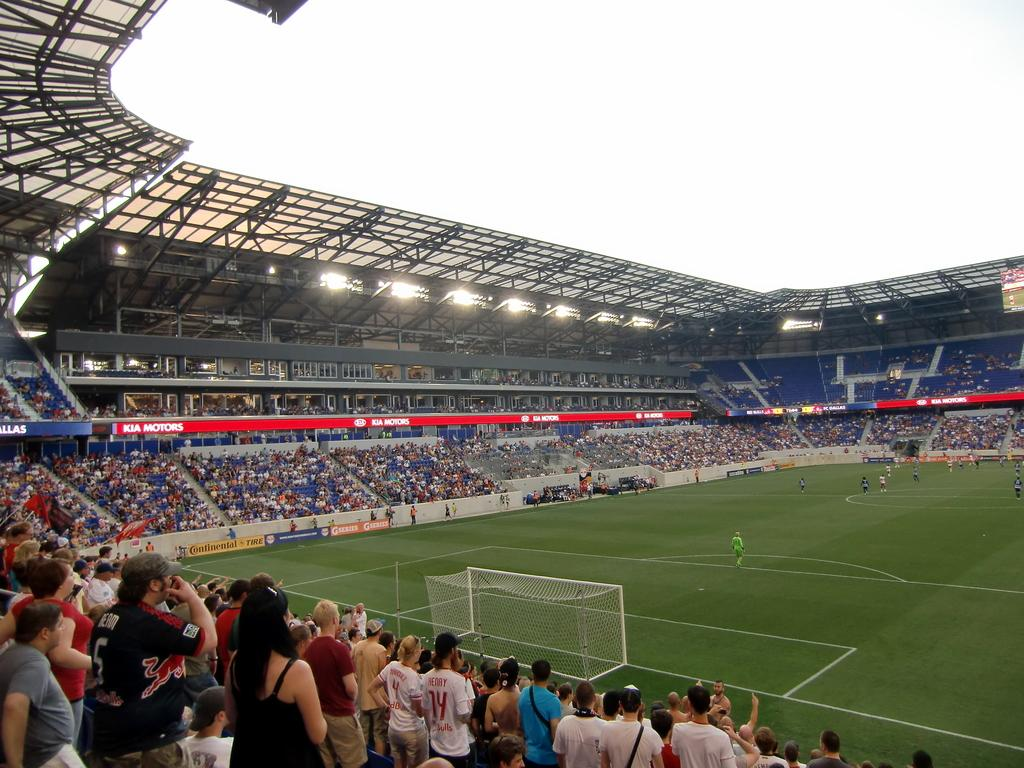Provide a one-sentence caption for the provided image. A stadium full of people looking out onto the field with Kia Motors being advertized around stadium. 